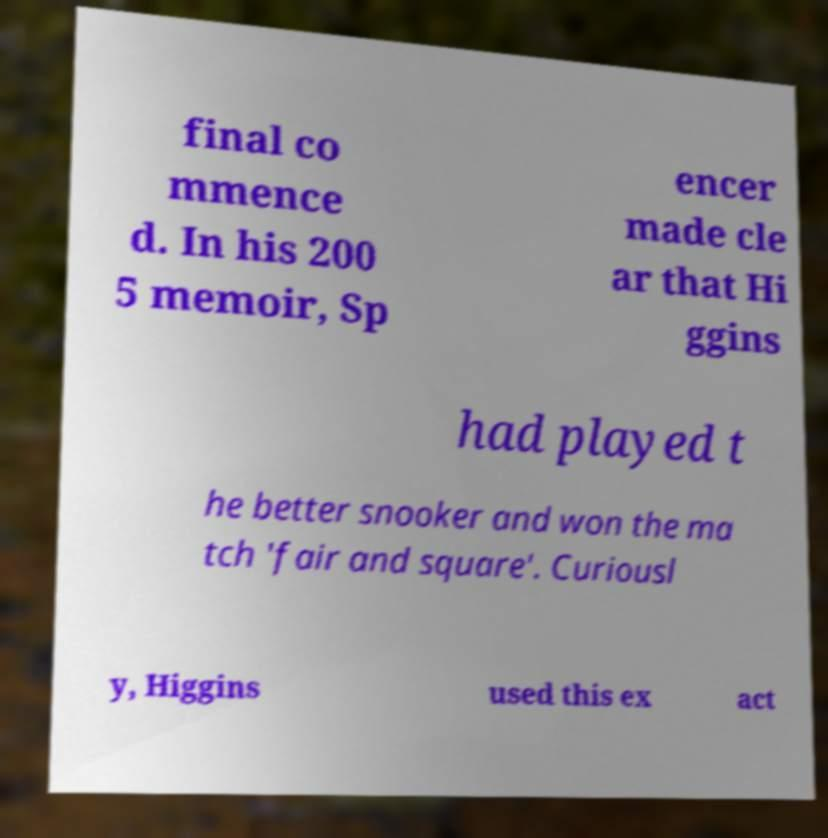Please read and relay the text visible in this image. What does it say? final co mmence d. In his 200 5 memoir, Sp encer made cle ar that Hi ggins had played t he better snooker and won the ma tch 'fair and square'. Curiousl y, Higgins used this ex act 